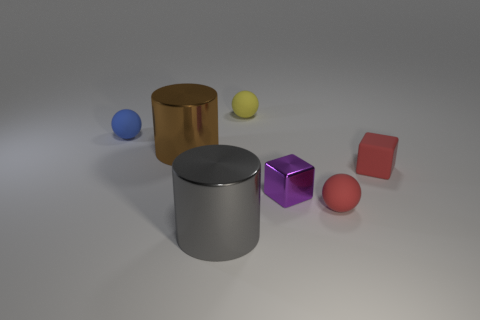Add 2 matte balls. How many objects exist? 9 Subtract all blocks. How many objects are left? 5 Subtract 0 blue cylinders. How many objects are left? 7 Subtract all brown cylinders. Subtract all brown shiny cylinders. How many objects are left? 5 Add 4 tiny yellow spheres. How many tiny yellow spheres are left? 5 Add 2 large gray shiny cylinders. How many large gray shiny cylinders exist? 3 